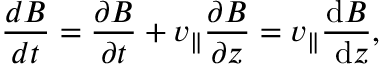Convert formula to latex. <formula><loc_0><loc_0><loc_500><loc_500>\frac { d B } { d t } = \frac { \partial B } { \partial t } + v _ { \| } \frac { \partial B } { \partial z } = v _ { \| } \frac { d B } { d z } ,</formula> 